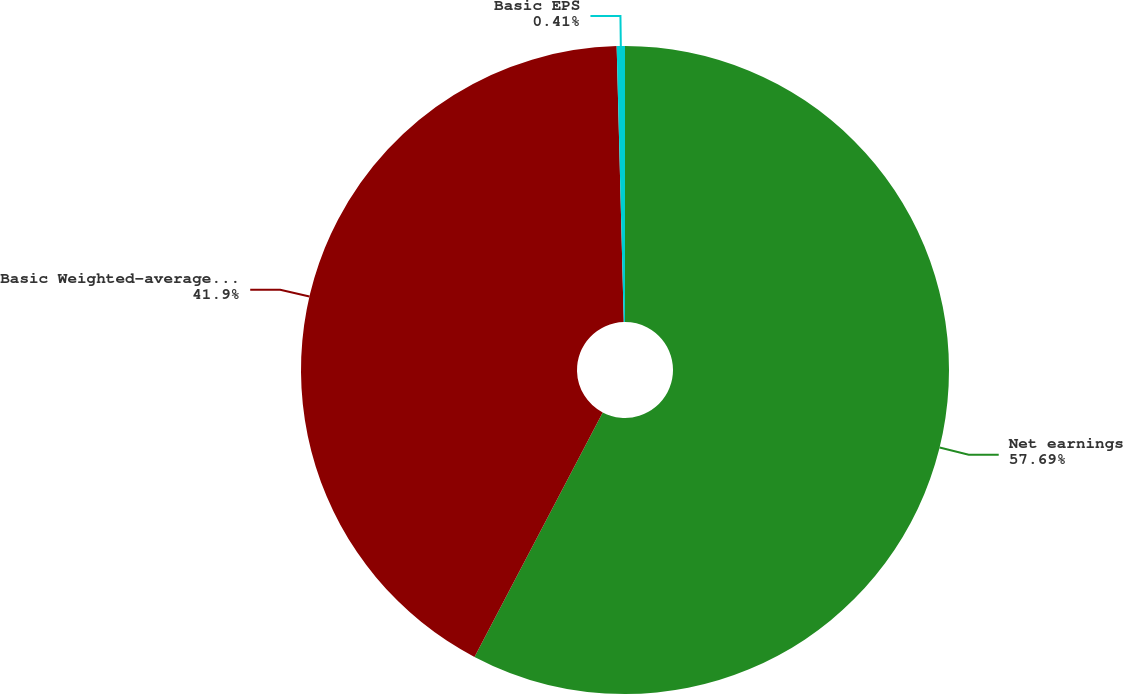Convert chart. <chart><loc_0><loc_0><loc_500><loc_500><pie_chart><fcel>Net earnings<fcel>Basic Weighted-average shares<fcel>Basic EPS<nl><fcel>57.69%<fcel>41.9%<fcel>0.41%<nl></chart> 